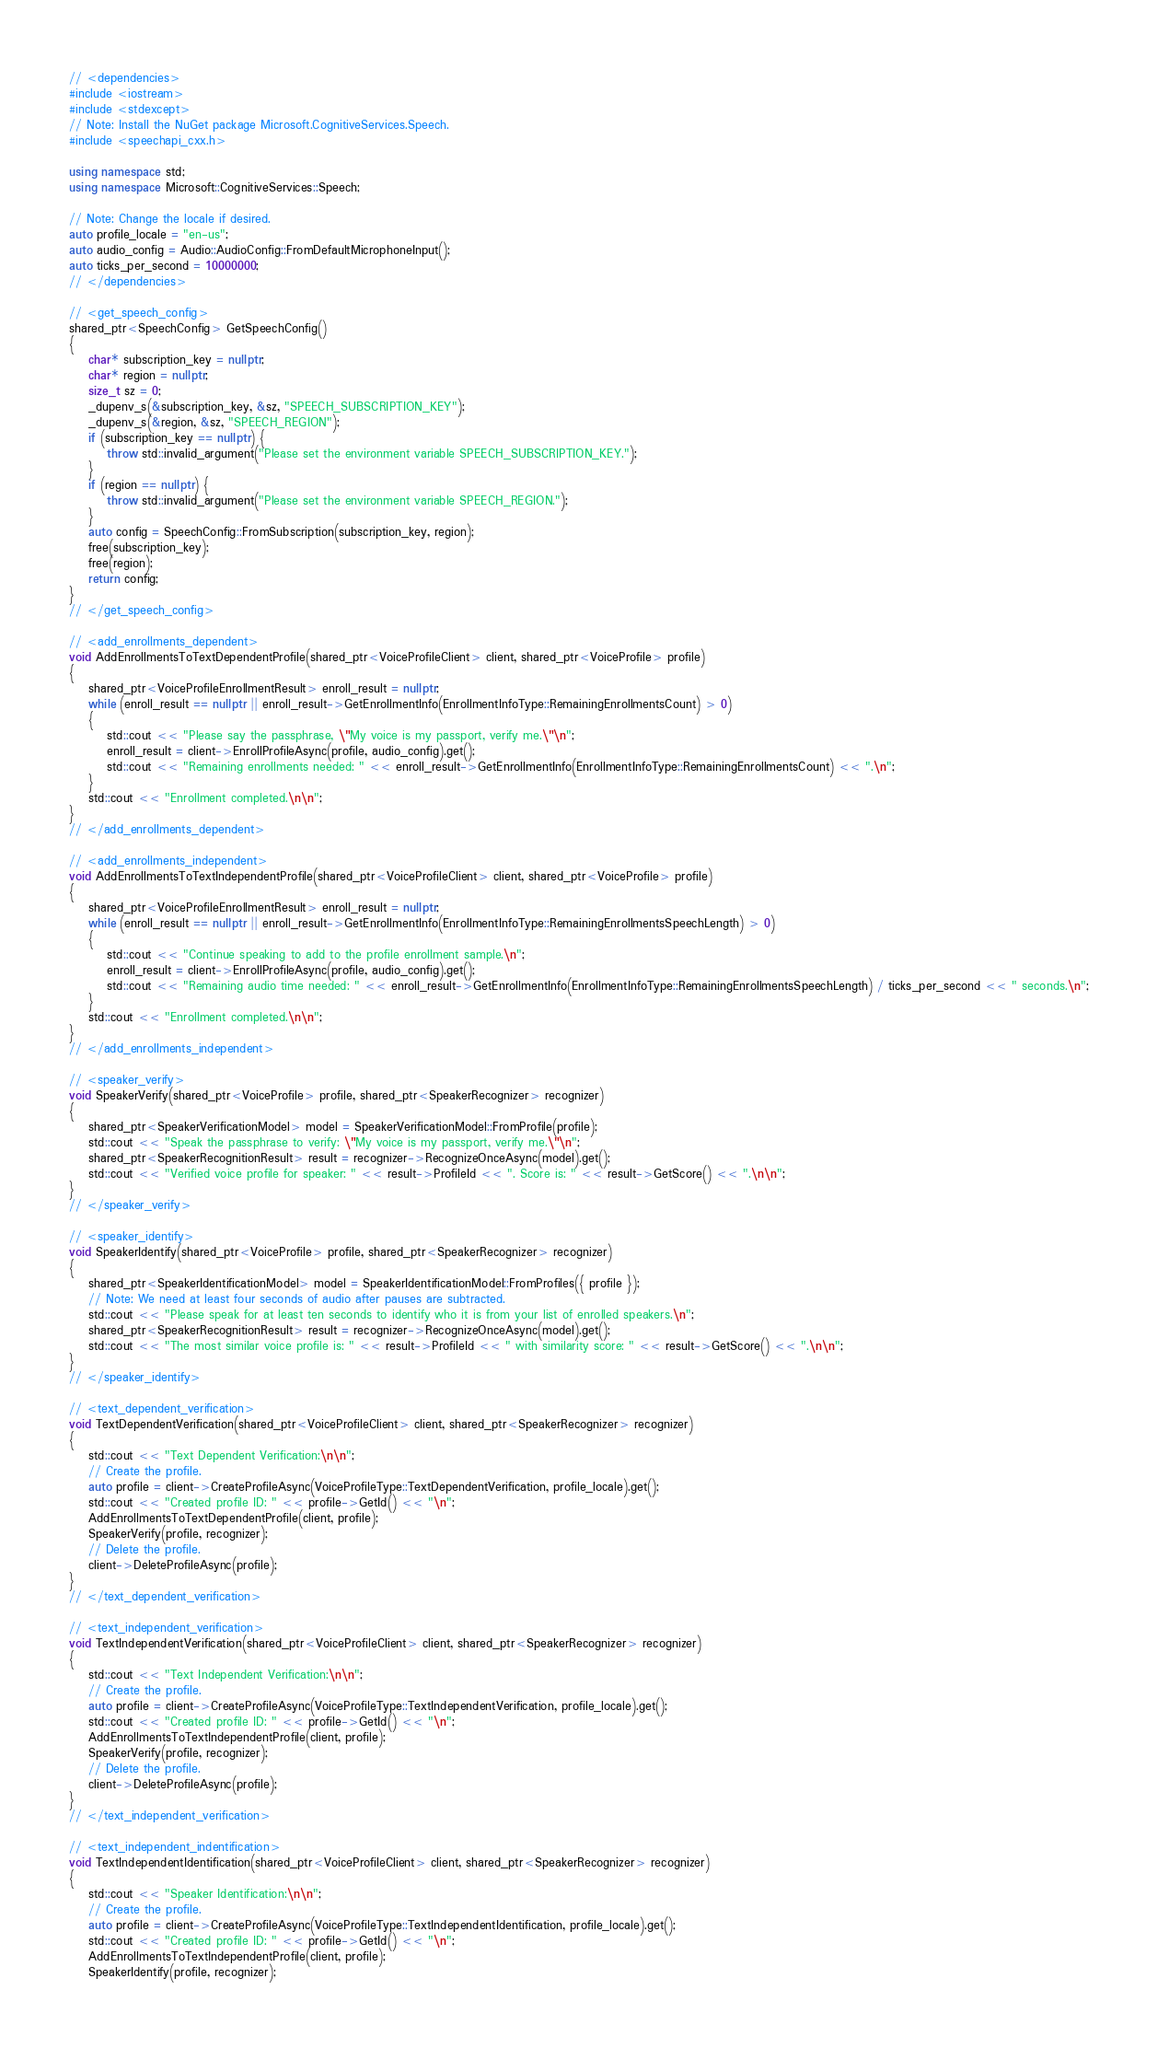Convert code to text. <code><loc_0><loc_0><loc_500><loc_500><_C++_>// <dependencies>
#include <iostream>
#include <stdexcept>
// Note: Install the NuGet package Microsoft.CognitiveServices.Speech.
#include <speechapi_cxx.h>

using namespace std;
using namespace Microsoft::CognitiveServices::Speech;

// Note: Change the locale if desired.
auto profile_locale = "en-us";
auto audio_config = Audio::AudioConfig::FromDefaultMicrophoneInput();
auto ticks_per_second = 10000000;
// </dependencies>

// <get_speech_config>
shared_ptr<SpeechConfig> GetSpeechConfig()
{
	char* subscription_key = nullptr;
	char* region = nullptr;
	size_t sz = 0;
	_dupenv_s(&subscription_key, &sz, "SPEECH_SUBSCRIPTION_KEY");
	_dupenv_s(&region, &sz, "SPEECH_REGION");
	if (subscription_key == nullptr) {
		throw std::invalid_argument("Please set the environment variable SPEECH_SUBSCRIPTION_KEY.");
	}
	if (region == nullptr) {
		throw std::invalid_argument("Please set the environment variable SPEECH_REGION.");
	}
	auto config = SpeechConfig::FromSubscription(subscription_key, region);
	free(subscription_key);
	free(region);
	return config;
}
// </get_speech_config>

// <add_enrollments_dependent>
void AddEnrollmentsToTextDependentProfile(shared_ptr<VoiceProfileClient> client, shared_ptr<VoiceProfile> profile)
{
	shared_ptr<VoiceProfileEnrollmentResult> enroll_result = nullptr;
	while (enroll_result == nullptr || enroll_result->GetEnrollmentInfo(EnrollmentInfoType::RemainingEnrollmentsCount) > 0)
	{
		std::cout << "Please say the passphrase, \"My voice is my passport, verify me.\"\n";
		enroll_result = client->EnrollProfileAsync(profile, audio_config).get();
		std::cout << "Remaining enrollments needed: " << enroll_result->GetEnrollmentInfo(EnrollmentInfoType::RemainingEnrollmentsCount) << ".\n";
	}
	std::cout << "Enrollment completed.\n\n";
}
// </add_enrollments_dependent>

// <add_enrollments_independent>
void AddEnrollmentsToTextIndependentProfile(shared_ptr<VoiceProfileClient> client, shared_ptr<VoiceProfile> profile)
{
	shared_ptr<VoiceProfileEnrollmentResult> enroll_result = nullptr;
	while (enroll_result == nullptr || enroll_result->GetEnrollmentInfo(EnrollmentInfoType::RemainingEnrollmentsSpeechLength) > 0)
	{
		std::cout << "Continue speaking to add to the profile enrollment sample.\n";
		enroll_result = client->EnrollProfileAsync(profile, audio_config).get();
		std::cout << "Remaining audio time needed: " << enroll_result->GetEnrollmentInfo(EnrollmentInfoType::RemainingEnrollmentsSpeechLength) / ticks_per_second << " seconds.\n";
	}
	std::cout << "Enrollment completed.\n\n";
}
// </add_enrollments_independent>

// <speaker_verify>
void SpeakerVerify(shared_ptr<VoiceProfile> profile, shared_ptr<SpeakerRecognizer> recognizer)
{
	shared_ptr<SpeakerVerificationModel> model = SpeakerVerificationModel::FromProfile(profile);
	std::cout << "Speak the passphrase to verify: \"My voice is my passport, verify me.\"\n";
	shared_ptr<SpeakerRecognitionResult> result = recognizer->RecognizeOnceAsync(model).get();
	std::cout << "Verified voice profile for speaker: " << result->ProfileId << ". Score is: " << result->GetScore() << ".\n\n";
}
// </speaker_verify>

// <speaker_identify>
void SpeakerIdentify(shared_ptr<VoiceProfile> profile, shared_ptr<SpeakerRecognizer> recognizer)
{
	shared_ptr<SpeakerIdentificationModel> model = SpeakerIdentificationModel::FromProfiles({ profile });
	// Note: We need at least four seconds of audio after pauses are subtracted.
	std::cout << "Please speak for at least ten seconds to identify who it is from your list of enrolled speakers.\n";
	shared_ptr<SpeakerRecognitionResult> result = recognizer->RecognizeOnceAsync(model).get();
	std::cout << "The most similar voice profile is: " << result->ProfileId << " with similarity score: " << result->GetScore() << ".\n\n";
}
// </speaker_identify>

// <text_dependent_verification>
void TextDependentVerification(shared_ptr<VoiceProfileClient> client, shared_ptr<SpeakerRecognizer> recognizer)
{
	std::cout << "Text Dependent Verification:\n\n";
	// Create the profile.
	auto profile = client->CreateProfileAsync(VoiceProfileType::TextDependentVerification, profile_locale).get();
	std::cout << "Created profile ID: " << profile->GetId() << "\n";
	AddEnrollmentsToTextDependentProfile(client, profile);
	SpeakerVerify(profile, recognizer);
	// Delete the profile.
	client->DeleteProfileAsync(profile);
}
// </text_dependent_verification>

// <text_independent_verification>
void TextIndependentVerification(shared_ptr<VoiceProfileClient> client, shared_ptr<SpeakerRecognizer> recognizer)
{
	std::cout << "Text Independent Verification:\n\n";
	// Create the profile.
	auto profile = client->CreateProfileAsync(VoiceProfileType::TextIndependentVerification, profile_locale).get();
	std::cout << "Created profile ID: " << profile->GetId() << "\n";
	AddEnrollmentsToTextIndependentProfile(client, profile);
	SpeakerVerify(profile, recognizer);
	// Delete the profile.
	client->DeleteProfileAsync(profile);
}
// </text_independent_verification>

// <text_independent_indentification>
void TextIndependentIdentification(shared_ptr<VoiceProfileClient> client, shared_ptr<SpeakerRecognizer> recognizer)
{
	std::cout << "Speaker Identification:\n\n";
	// Create the profile.
	auto profile = client->CreateProfileAsync(VoiceProfileType::TextIndependentIdentification, profile_locale).get();
	std::cout << "Created profile ID: " << profile->GetId() << "\n";
	AddEnrollmentsToTextIndependentProfile(client, profile);
	SpeakerIdentify(profile, recognizer);</code> 